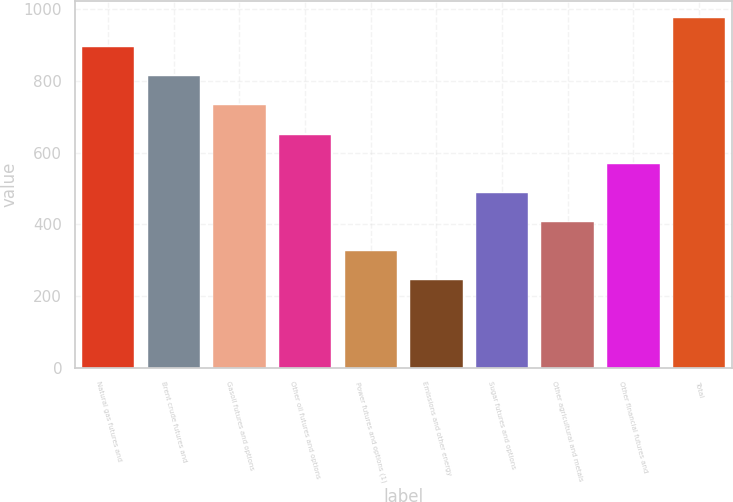<chart> <loc_0><loc_0><loc_500><loc_500><bar_chart><fcel>Natural gas futures and<fcel>Brent crude futures and<fcel>Gasoil futures and options<fcel>Other oil futures and options<fcel>Power futures and options (1)<fcel>Emissions and other energy<fcel>Sugar futures and options<fcel>Other agricultural and metals<fcel>Other financial futures and<fcel>Total<nl><fcel>894.22<fcel>812.99<fcel>731.76<fcel>650.53<fcel>325.61<fcel>244.38<fcel>488.07<fcel>406.84<fcel>569.3<fcel>975.45<nl></chart> 